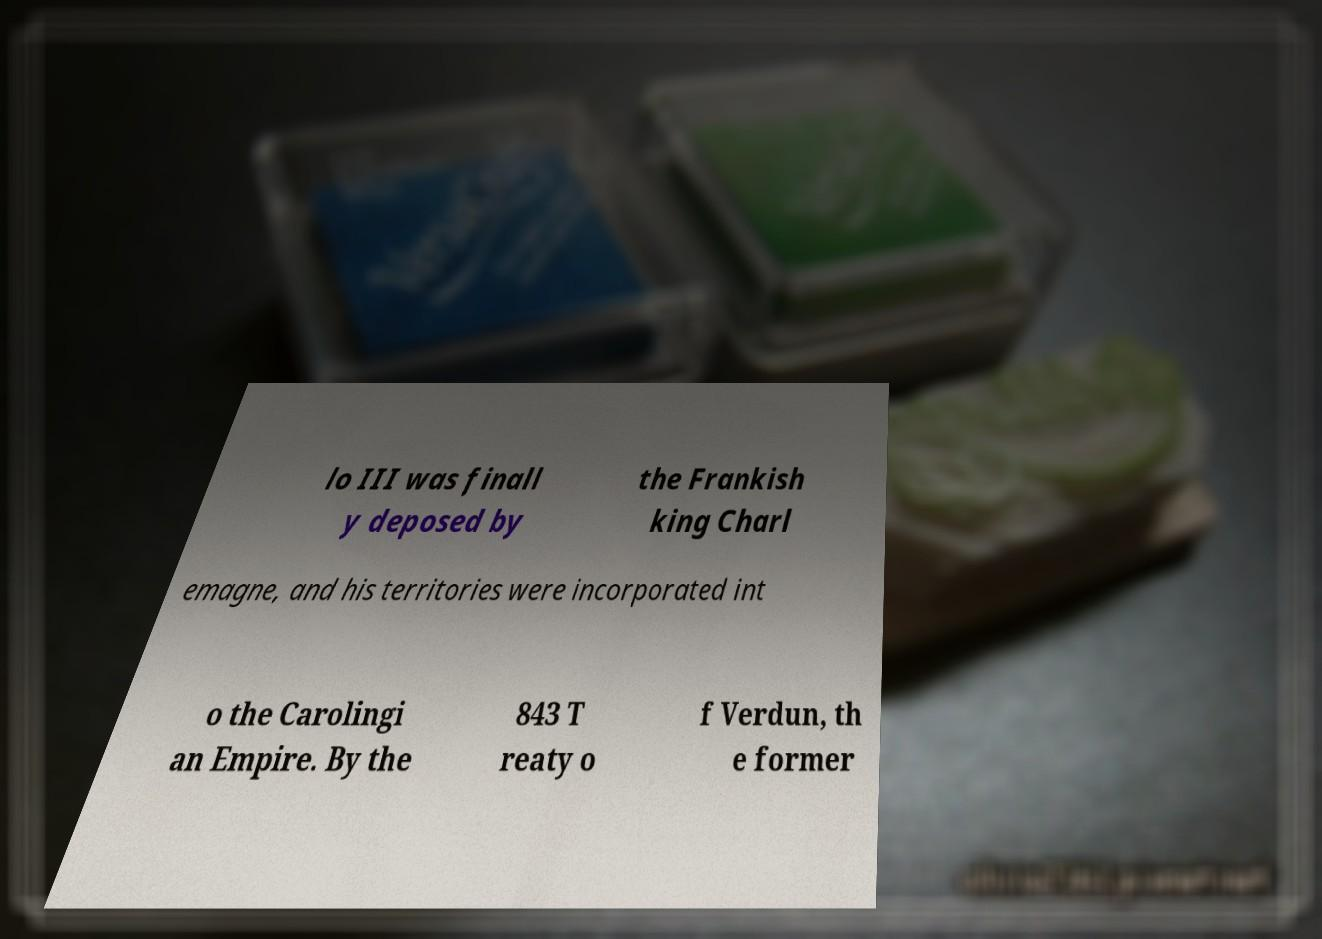Could you extract and type out the text from this image? lo III was finall y deposed by the Frankish king Charl emagne, and his territories were incorporated int o the Carolingi an Empire. By the 843 T reaty o f Verdun, th e former 